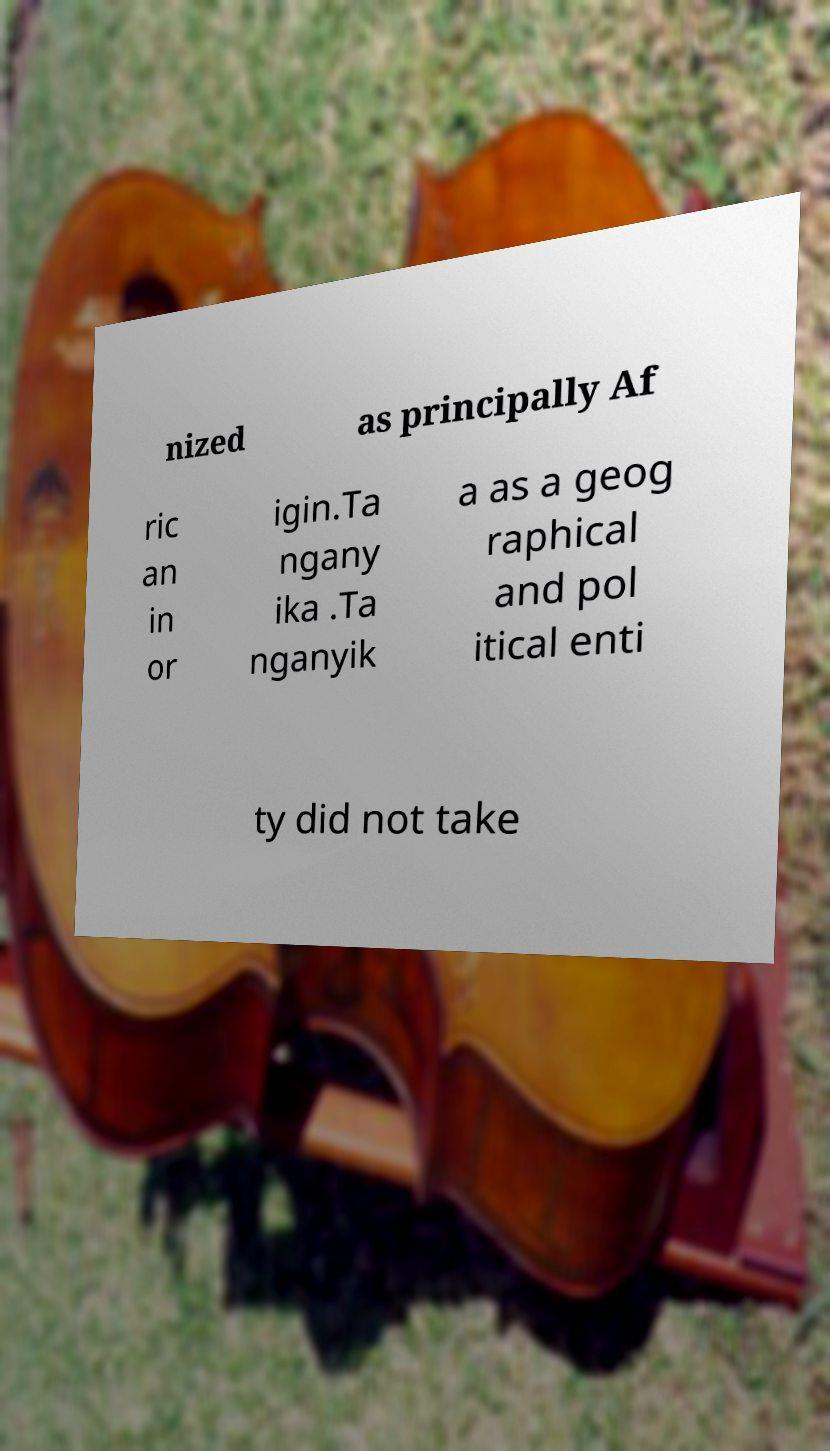Can you accurately transcribe the text from the provided image for me? nized as principally Af ric an in or igin.Ta ngany ika .Ta nganyik a as a geog raphical and pol itical enti ty did not take 